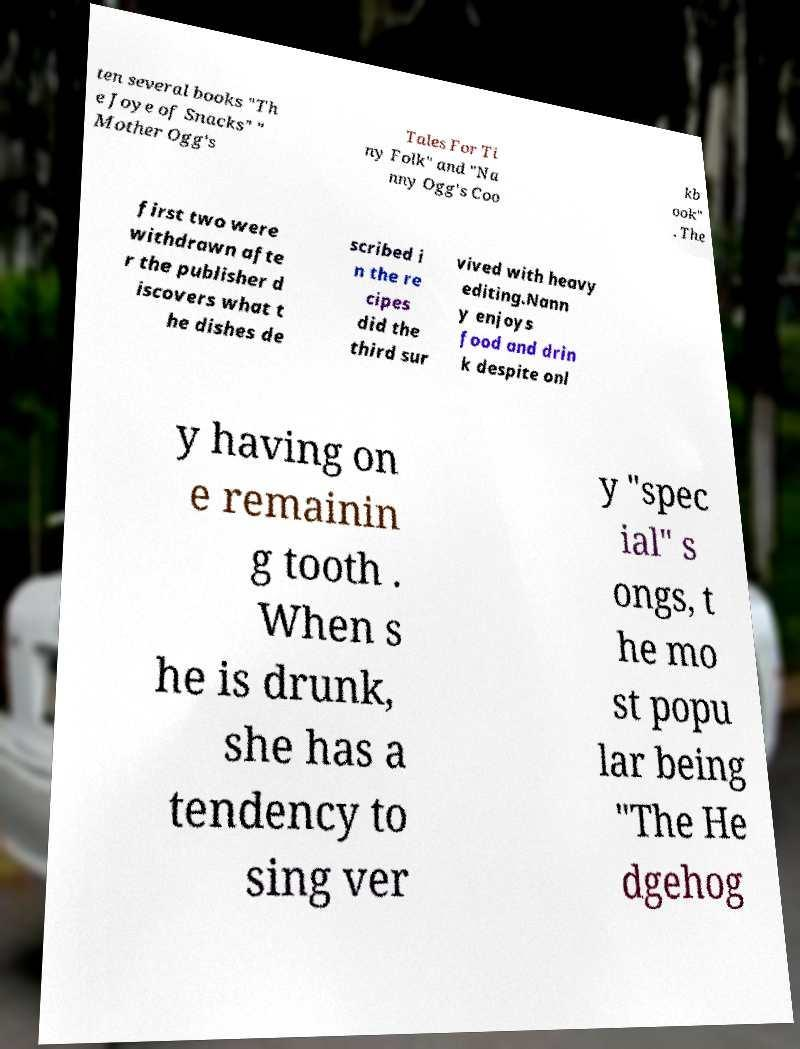Can you read and provide the text displayed in the image?This photo seems to have some interesting text. Can you extract and type it out for me? ten several books "Th e Joye of Snacks" " Mother Ogg's Tales For Ti ny Folk" and "Na nny Ogg's Coo kb ook" . The first two were withdrawn afte r the publisher d iscovers what t he dishes de scribed i n the re cipes did the third sur vived with heavy editing.Nann y enjoys food and drin k despite onl y having on e remainin g tooth . When s he is drunk, she has a tendency to sing ver y "spec ial" s ongs, t he mo st popu lar being "The He dgehog 